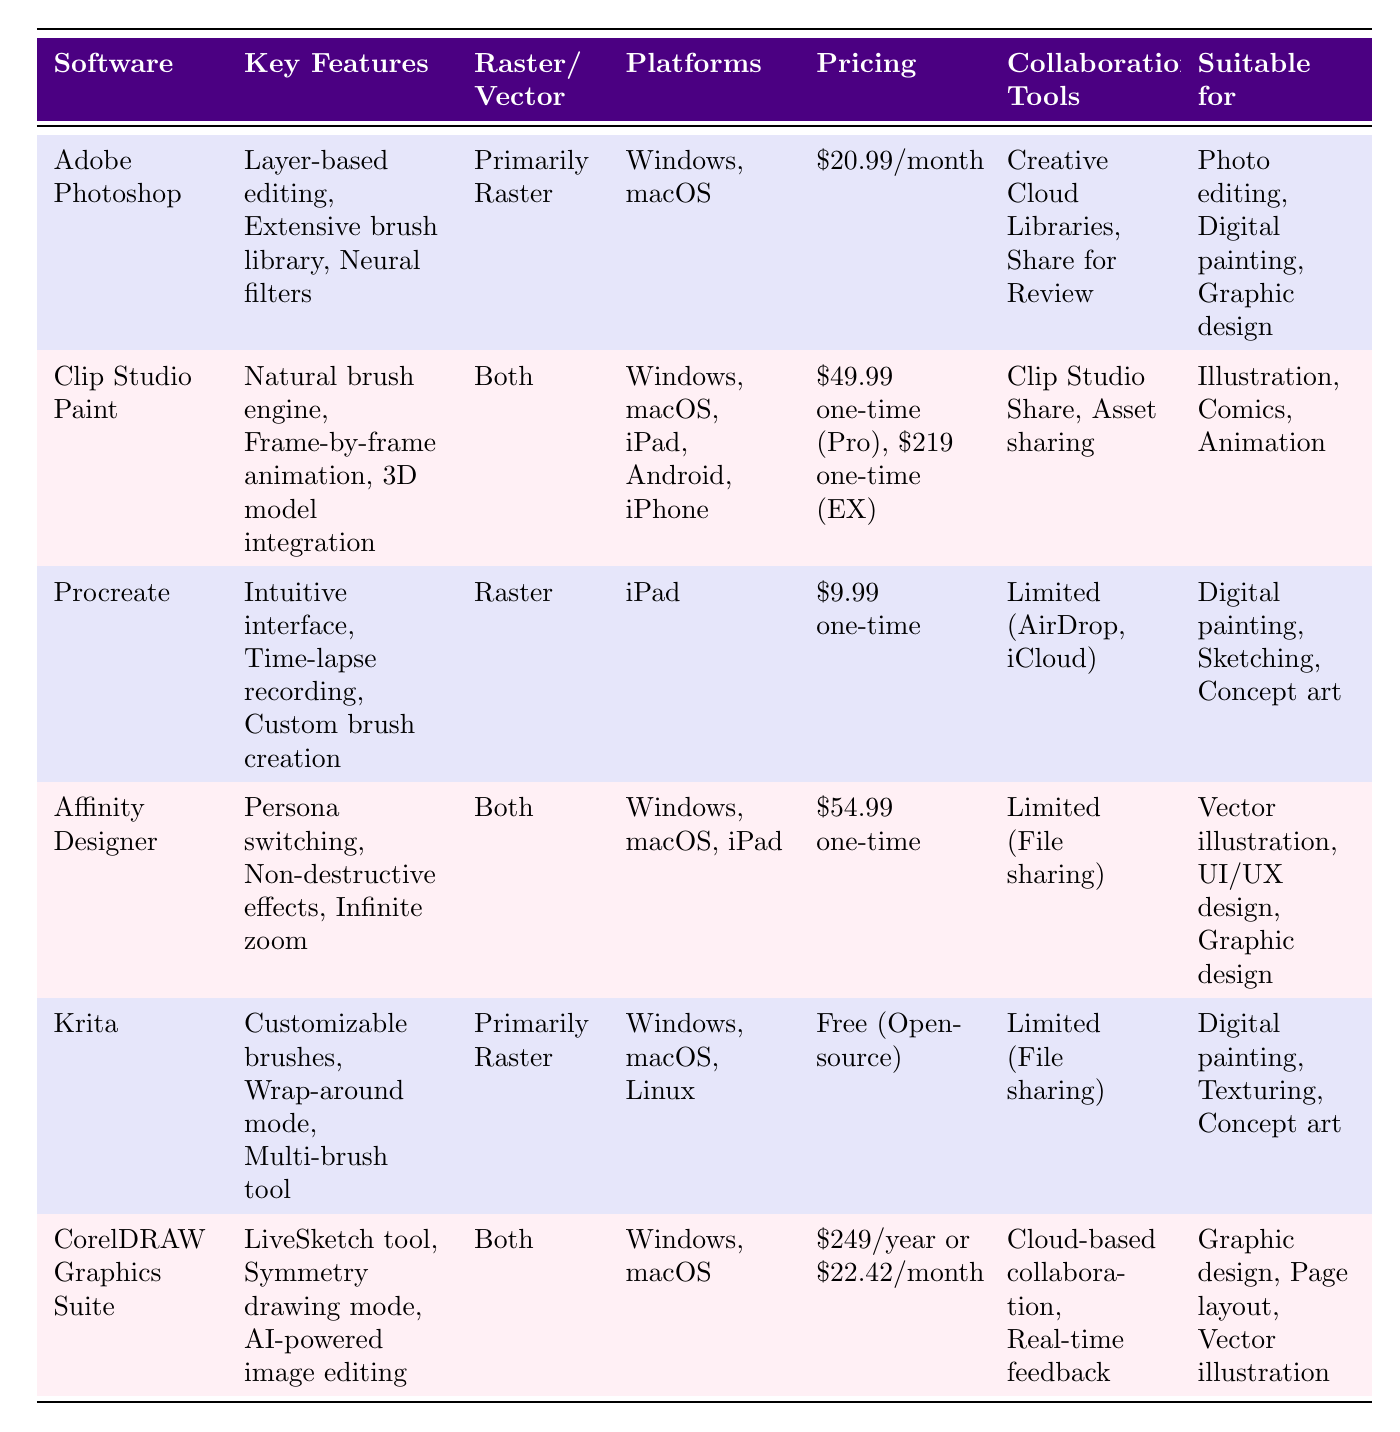What platforms does Procreate support? Procreate is indicated in the "Platforms" column of the table. It lists "iPad" as the only supported platform.
Answer: iPad Which software offers a free version? The table lists the "Pricing" column for each software. It shows "Free (Open-source)" for Krita, indicating that it has a free version available.
Answer: Yes What are the key features of CorelDRAW Graphics Suite? To find the key features, refer to the "Key Features" column corresponding to CorelDRAW Graphics Suite. It lists "LiveSketch tool, Symmetry drawing mode, AI-powered image editing."
Answer: LiveSketch tool, Symmetry drawing mode, AI-powered image editing How much more expensive is Clip Studio Paint (EX) compared to Procreate? Procreate costs $9.99 one-time while Clip Studio Paint (EX) costs $219 one-time. The difference is calculated by subtracting Procreate's price from Clip Studio Paint (EX): 219 - 9.99 = 209.01.
Answer: 209.01 Does Adobe Photoshop have collaboration tools? Checking the "Collaboration Tools" column for Adobe Photoshop shows "Creative Cloud Libraries, Share for Review," indicating there are collaboration tools available.
Answer: Yes Which software is suitable for UI/UX design? The "Suitable for" column indicates that Affinity Designer is listed for "UI/UX design." Thus, Affinity Designer is the software that is suitable for this purpose.
Answer: Affinity Designer What is the total cost of using CorelDRAW Graphics Suite for one year? The table shows CorelDRAW Graphics Suite has a yearly price of $249. Therefore, the total cost of using it for one year is simply $249.
Answer: 249 How many software options are compatible with mobile platforms? The "Platforms" column shows that Clip Studio Paint and Procreate are compatible with mobile platforms (iPad, Android, iPhone). Therefore, there are 2 software options.
Answer: 2 Which software primarily focuses on raster graphics? In the "Raster/Vector" column, both "Adobe Photoshop" and "Krita" are marked as "Primarily Raster," indicating that they primarily focus on raster graphics.
Answer: Adobe Photoshop, Krita What is the average pricing of the software listed? To calculate the average pricing, convert all pricing values to numeric format: Adobe Photoshop: 20.99, Clip Studio Paint (Pro): 49.99, Clip Studio Paint (EX): 219, Procreate: 9.99, Affinity Designer: 54.99, Krita: 0, CorelDRAW: 22.42 (monthly). The total costs are 20.99 + 49.99 + 219 + 9.99 + 54.99 + 0 + 22.42 = 377.38, and there are 6 software options. The average is 377.38 / 6 ≈ 62.90.
Answer: 62.90 